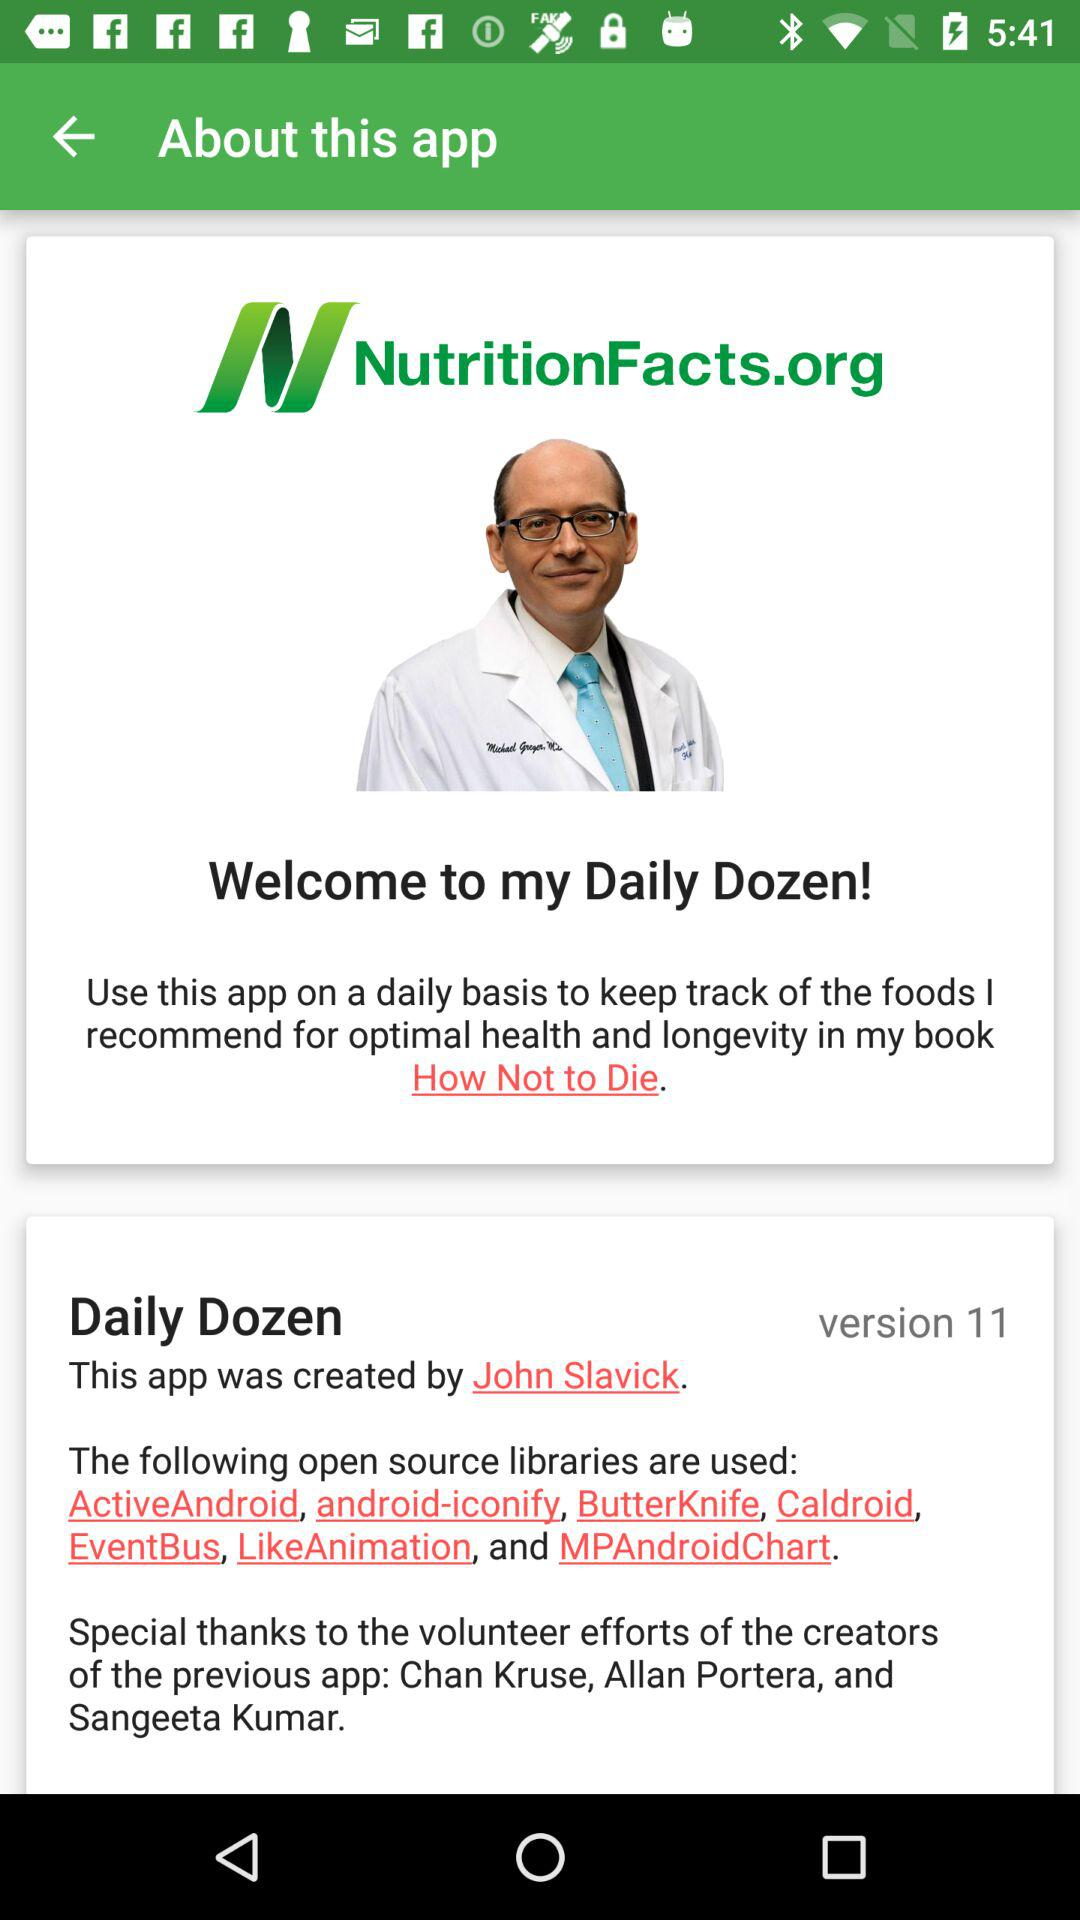How many open source libraries are used?
Answer the question using a single word or phrase. 7 